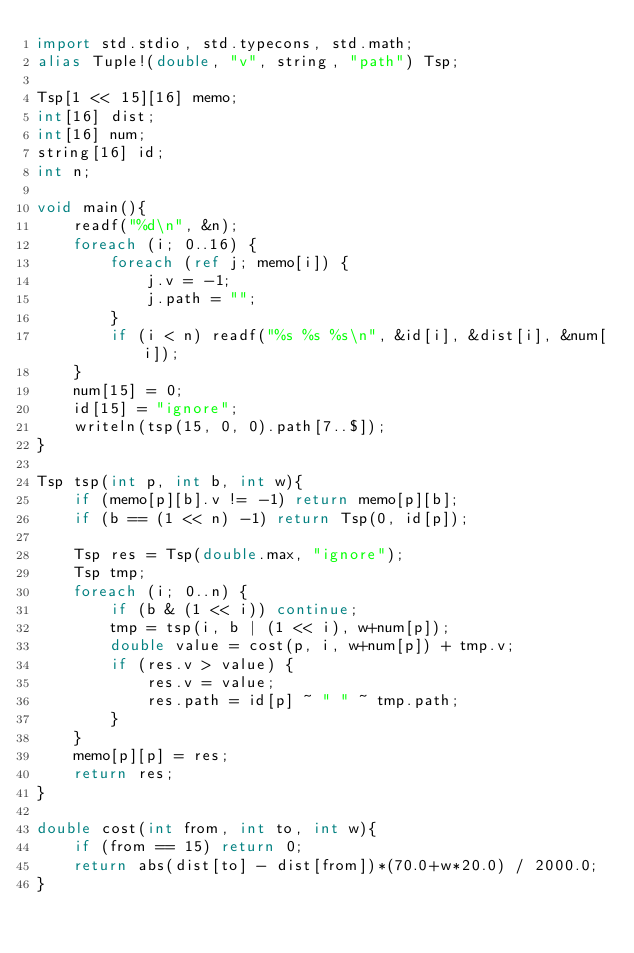<code> <loc_0><loc_0><loc_500><loc_500><_D_>import std.stdio, std.typecons, std.math;
alias Tuple!(double, "v", string, "path") Tsp; 

Tsp[1 << 15][16] memo;
int[16] dist;
int[16] num;
string[16] id;
int n;

void main(){
	readf("%d\n", &n);
	foreach (i; 0..16) {
		foreach (ref j; memo[i]) {
			j.v = -1;
			j.path = "";
		}
		if (i < n) readf("%s %s %s\n", &id[i], &dist[i], &num[i]);
	}
	num[15] = 0;
	id[15] = "ignore";
	writeln(tsp(15, 0, 0).path[7..$]);
}

Tsp tsp(int p, int b, int w){
	if (memo[p][b].v != -1) return memo[p][b];
	if (b == (1 << n) -1) return Tsp(0, id[p]);

	Tsp res = Tsp(double.max, "ignore");
	Tsp tmp;
	foreach (i; 0..n) {
		if (b & (1 << i)) continue;
		tmp = tsp(i, b | (1 << i), w+num[p]);
		double value = cost(p, i, w+num[p]) + tmp.v;
		if (res.v > value) {
			res.v = value;
			res.path = id[p] ~ " " ~ tmp.path;
		}
	}
	memo[p][p] = res;
	return res;
}

double cost(int from, int to, int w){
	if (from == 15) return 0;
	return abs(dist[to] - dist[from])*(70.0+w*20.0) / 2000.0;
}</code> 